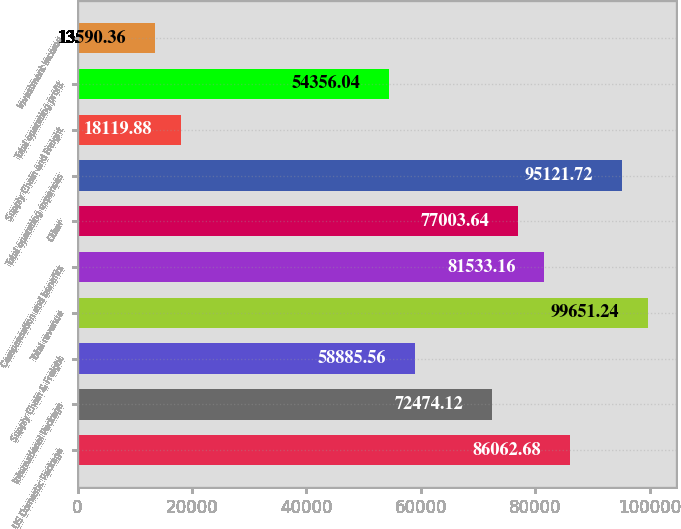Convert chart. <chart><loc_0><loc_0><loc_500><loc_500><bar_chart><fcel>US Domestic Package<fcel>International Package<fcel>Supply Chain & Freight<fcel>Total revenue<fcel>Compensation and benefits<fcel>Other<fcel>Total operating expenses<fcel>Supply Chain and Freight<fcel>Total operating profit<fcel>Investment income<nl><fcel>86062.7<fcel>72474.1<fcel>58885.6<fcel>99651.2<fcel>81533.2<fcel>77003.6<fcel>95121.7<fcel>18119.9<fcel>54356<fcel>13590.4<nl></chart> 